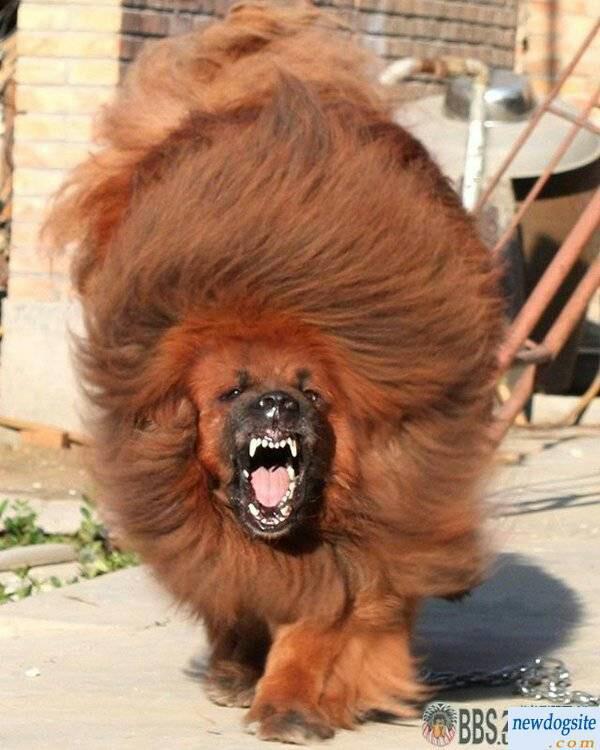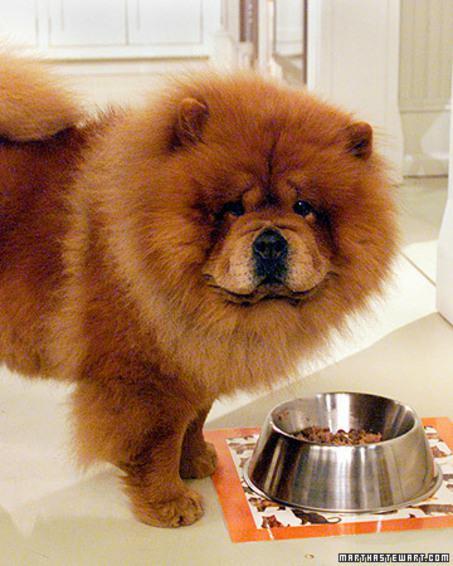The first image is the image on the left, the second image is the image on the right. Examine the images to the left and right. Is the description "A single dog is lying down in the image on the right." accurate? Answer yes or no. No. The first image is the image on the left, the second image is the image on the right. Evaluate the accuracy of this statement regarding the images: "One image features a chow standing on a red brick-colored surface and looking upward.". Is it true? Answer yes or no. No. 